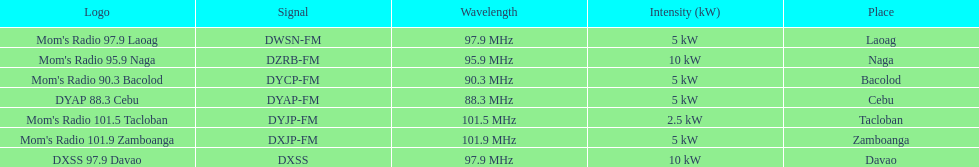What are the total number of radio stations on this list? 7. 